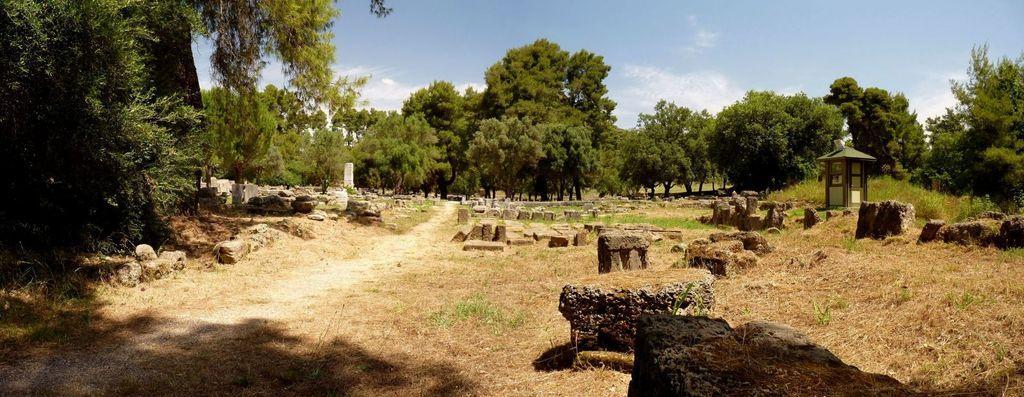Describe this image in one or two sentences. In this image in the middle there are trees, stones, house, grass, plants, land. At the top there are sky and clouds. 